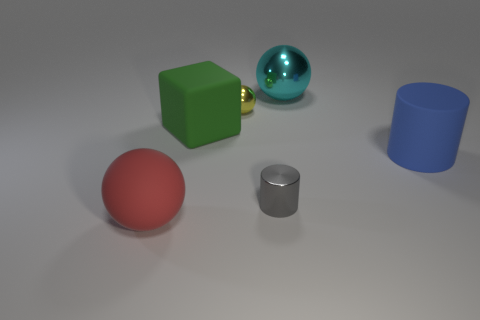Add 3 blue blocks. How many objects exist? 9 Subtract all blocks. How many objects are left? 5 Subtract 1 gray cylinders. How many objects are left? 5 Subtract all big blue matte objects. Subtract all large cylinders. How many objects are left? 4 Add 5 yellow spheres. How many yellow spheres are left? 6 Add 5 big blue matte blocks. How many big blue matte blocks exist? 5 